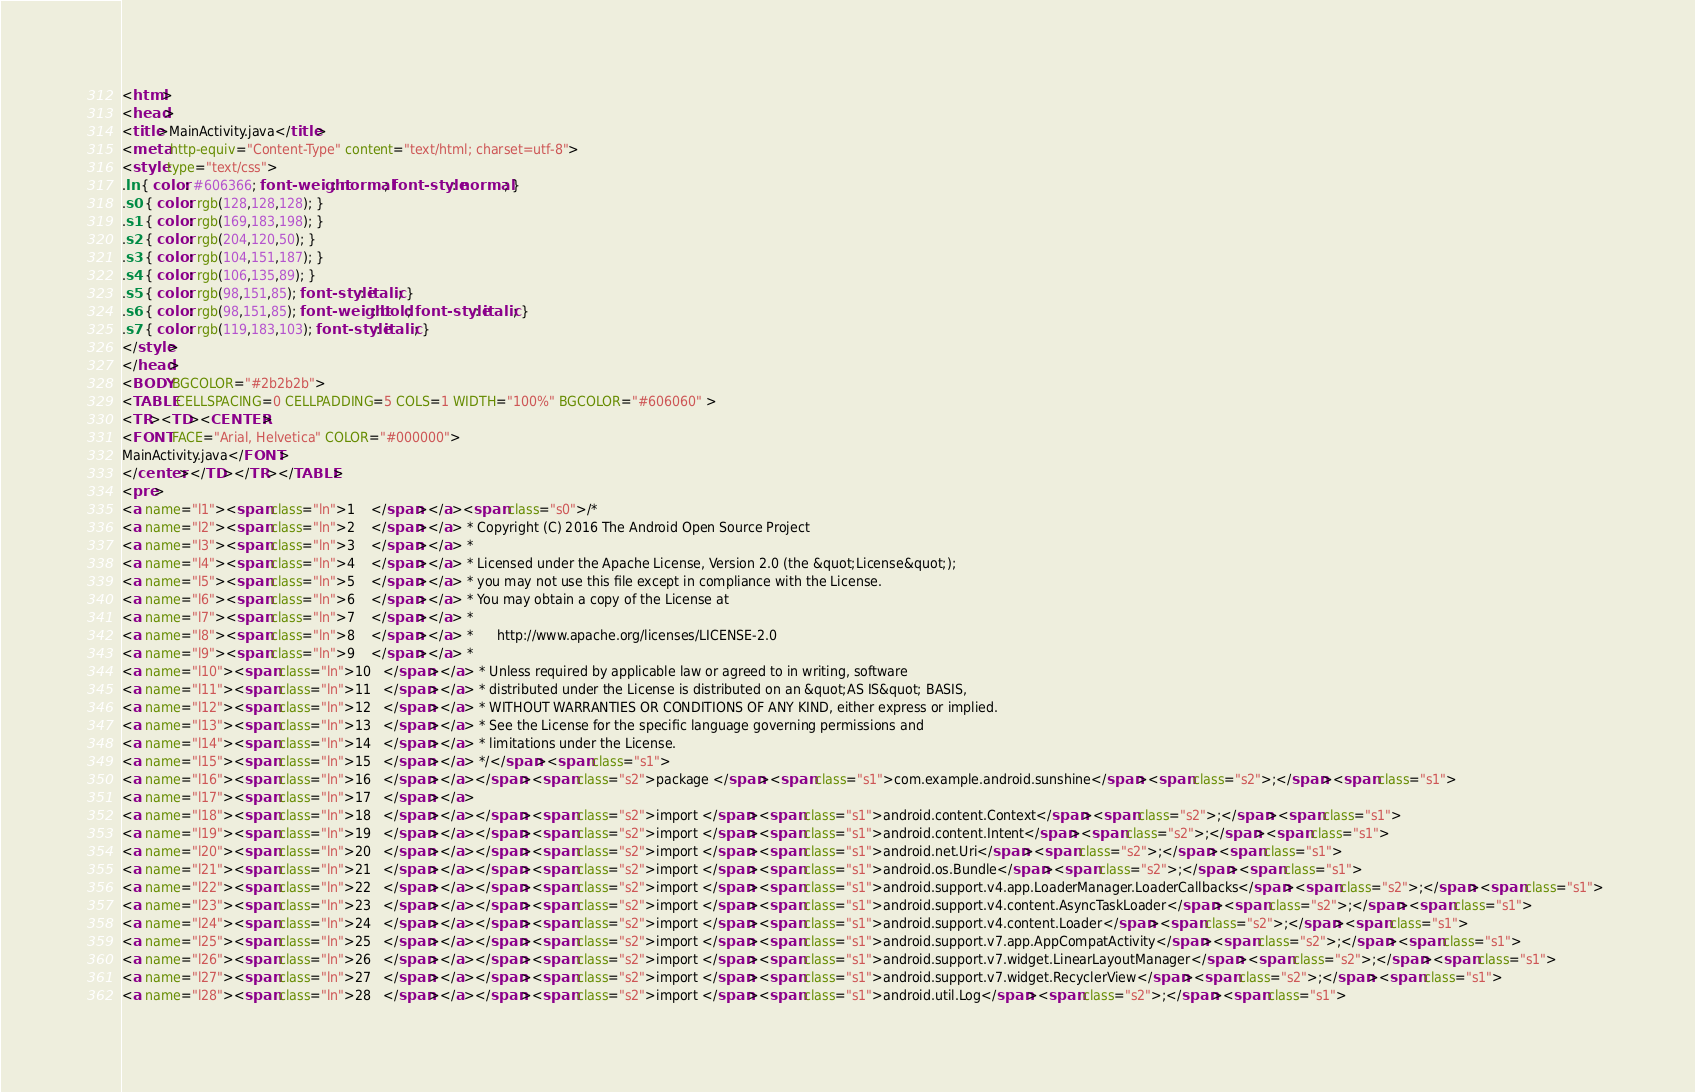<code> <loc_0><loc_0><loc_500><loc_500><_HTML_><html>
<head>
<title>MainActivity.java</title>
<meta http-equiv="Content-Type" content="text/html; charset=utf-8">
<style type="text/css">
.ln { color: #606366; font-weight: normal; font-style: normal; }
.s0 { color: rgb(128,128,128); }
.s1 { color: rgb(169,183,198); }
.s2 { color: rgb(204,120,50); }
.s3 { color: rgb(104,151,187); }
.s4 { color: rgb(106,135,89); }
.s5 { color: rgb(98,151,85); font-style: italic; }
.s6 { color: rgb(98,151,85); font-weight: bold; font-style: italic; }
.s7 { color: rgb(119,183,103); font-style: italic; }
</style>
</head>
<BODY BGCOLOR="#2b2b2b">
<TABLE CELLSPACING=0 CELLPADDING=5 COLS=1 WIDTH="100%" BGCOLOR="#606060" >
<TR><TD><CENTER>
<FONT FACE="Arial, Helvetica" COLOR="#000000">
MainActivity.java</FONT>
</center></TD></TR></TABLE>
<pre>
<a name="l1"><span class="ln">1    </span></a><span class="s0">/* 
<a name="l2"><span class="ln">2    </span></a> * Copyright (C) 2016 The Android Open Source Project 
<a name="l3"><span class="ln">3    </span></a> * 
<a name="l4"><span class="ln">4    </span></a> * Licensed under the Apache License, Version 2.0 (the &quot;License&quot;); 
<a name="l5"><span class="ln">5    </span></a> * you may not use this file except in compliance with the License. 
<a name="l6"><span class="ln">6    </span></a> * You may obtain a copy of the License at 
<a name="l7"><span class="ln">7    </span></a> * 
<a name="l8"><span class="ln">8    </span></a> *      http://www.apache.org/licenses/LICENSE-2.0 
<a name="l9"><span class="ln">9    </span></a> * 
<a name="l10"><span class="ln">10   </span></a> * Unless required by applicable law or agreed to in writing, software 
<a name="l11"><span class="ln">11   </span></a> * distributed under the License is distributed on an &quot;AS IS&quot; BASIS, 
<a name="l12"><span class="ln">12   </span></a> * WITHOUT WARRANTIES OR CONDITIONS OF ANY KIND, either express or implied. 
<a name="l13"><span class="ln">13   </span></a> * See the License for the specific language governing permissions and 
<a name="l14"><span class="ln">14   </span></a> * limitations under the License. 
<a name="l15"><span class="ln">15   </span></a> */</span><span class="s1"> 
<a name="l16"><span class="ln">16   </span></a></span><span class="s2">package </span><span class="s1">com.example.android.sunshine</span><span class="s2">;</span><span class="s1"> 
<a name="l17"><span class="ln">17   </span></a> 
<a name="l18"><span class="ln">18   </span></a></span><span class="s2">import </span><span class="s1">android.content.Context</span><span class="s2">;</span><span class="s1"> 
<a name="l19"><span class="ln">19   </span></a></span><span class="s2">import </span><span class="s1">android.content.Intent</span><span class="s2">;</span><span class="s1"> 
<a name="l20"><span class="ln">20   </span></a></span><span class="s2">import </span><span class="s1">android.net.Uri</span><span class="s2">;</span><span class="s1"> 
<a name="l21"><span class="ln">21   </span></a></span><span class="s2">import </span><span class="s1">android.os.Bundle</span><span class="s2">;</span><span class="s1"> 
<a name="l22"><span class="ln">22   </span></a></span><span class="s2">import </span><span class="s1">android.support.v4.app.LoaderManager.LoaderCallbacks</span><span class="s2">;</span><span class="s1"> 
<a name="l23"><span class="ln">23   </span></a></span><span class="s2">import </span><span class="s1">android.support.v4.content.AsyncTaskLoader</span><span class="s2">;</span><span class="s1"> 
<a name="l24"><span class="ln">24   </span></a></span><span class="s2">import </span><span class="s1">android.support.v4.content.Loader</span><span class="s2">;</span><span class="s1"> 
<a name="l25"><span class="ln">25   </span></a></span><span class="s2">import </span><span class="s1">android.support.v7.app.AppCompatActivity</span><span class="s2">;</span><span class="s1"> 
<a name="l26"><span class="ln">26   </span></a></span><span class="s2">import </span><span class="s1">android.support.v7.widget.LinearLayoutManager</span><span class="s2">;</span><span class="s1"> 
<a name="l27"><span class="ln">27   </span></a></span><span class="s2">import </span><span class="s1">android.support.v7.widget.RecyclerView</span><span class="s2">;</span><span class="s1"> 
<a name="l28"><span class="ln">28   </span></a></span><span class="s2">import </span><span class="s1">android.util.Log</span><span class="s2">;</span><span class="s1"> </code> 